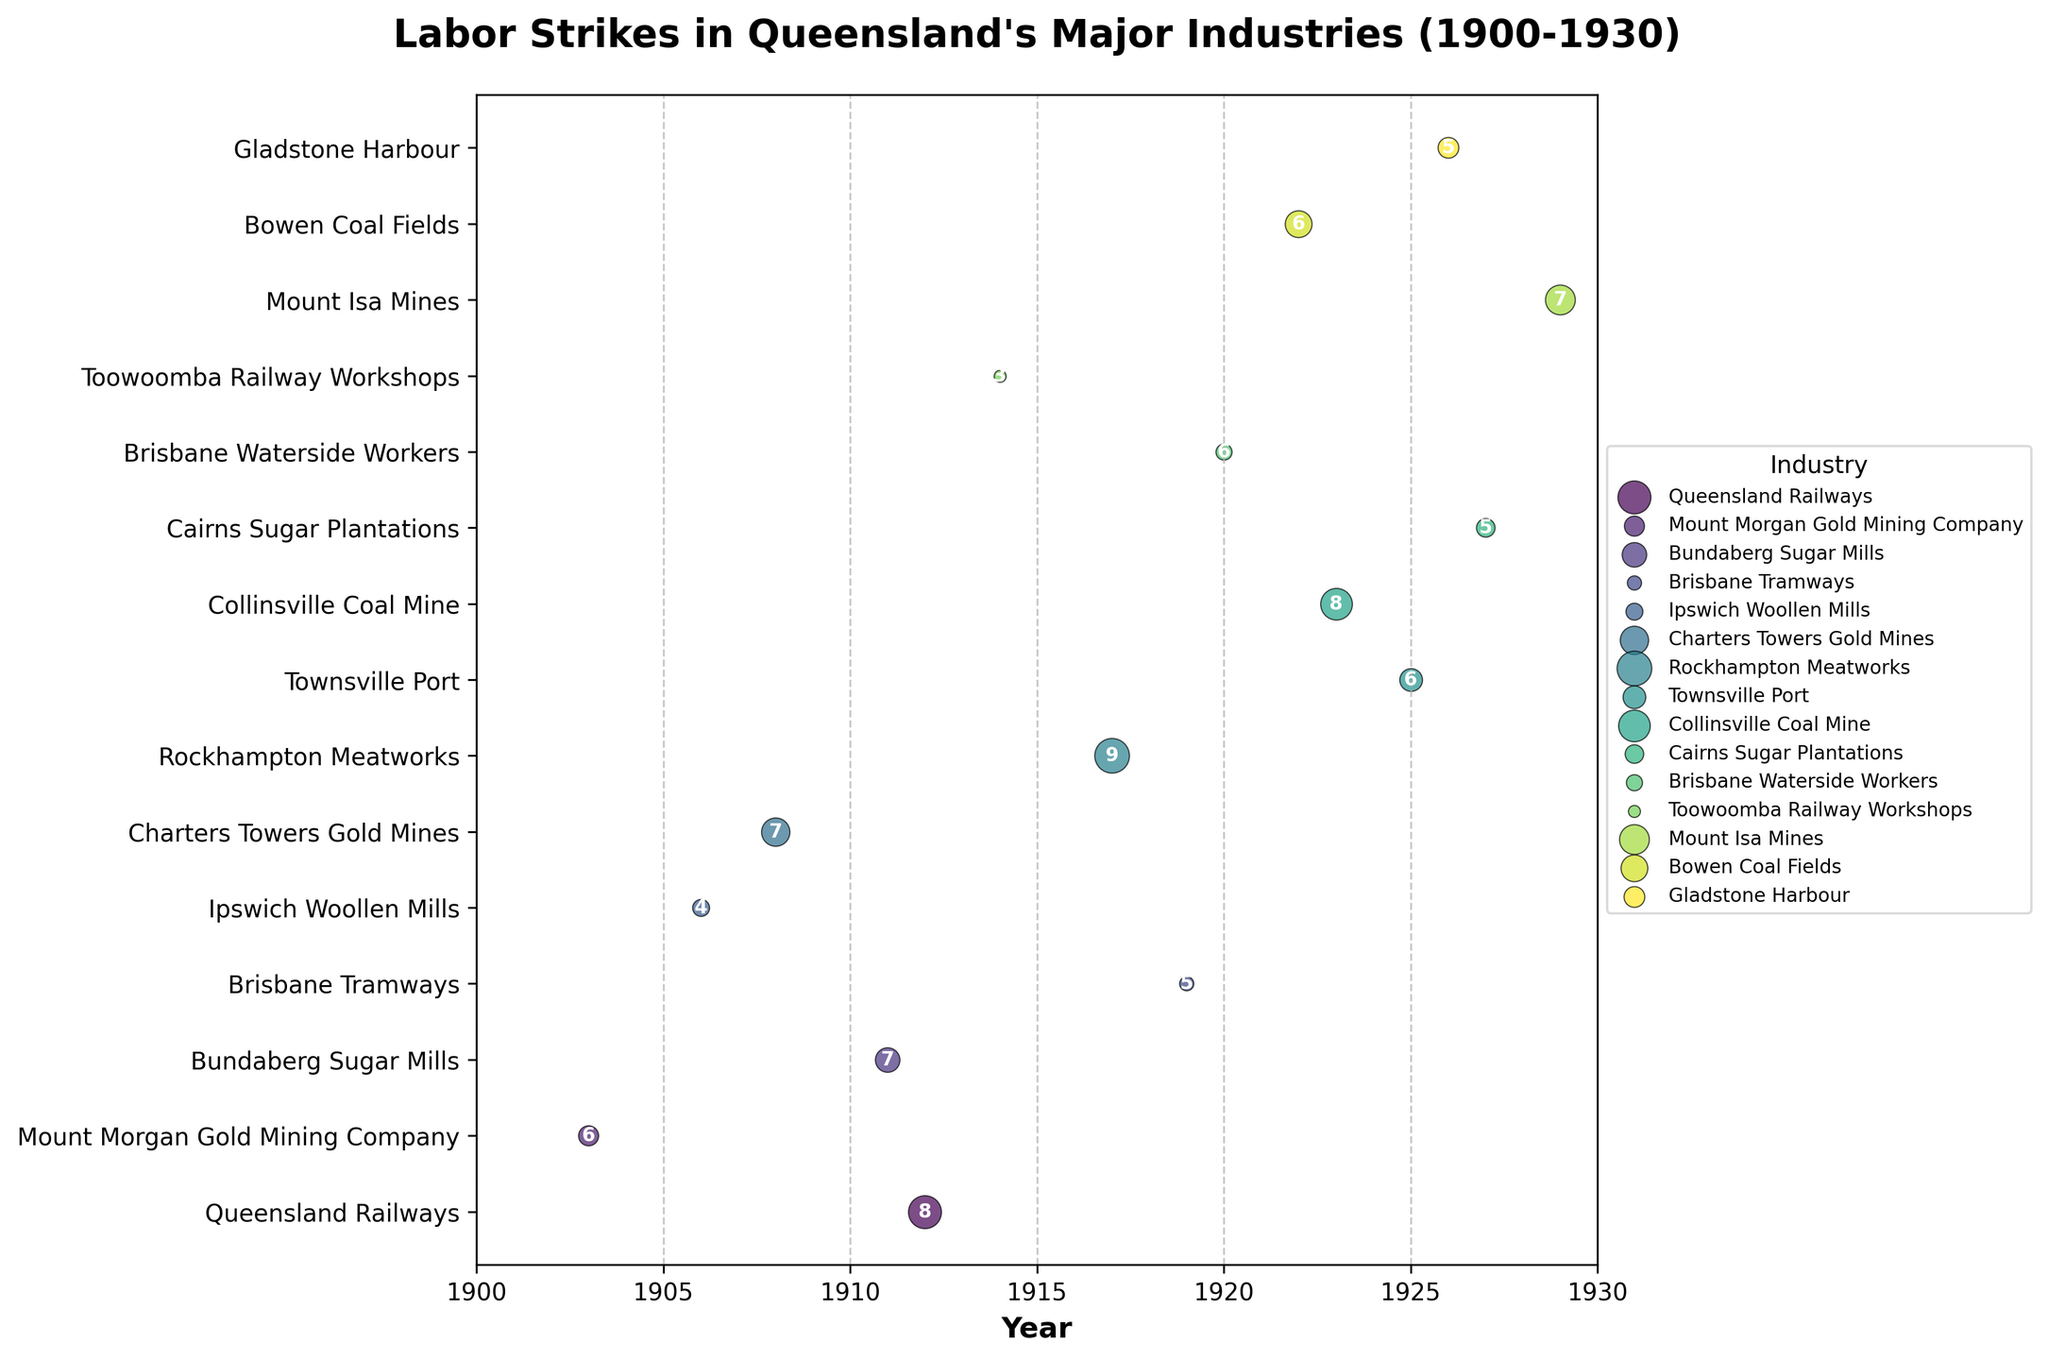What is the title of the plot? The title is located at the top of the plot and summarizes the data being displayed, which is about labor strikes in Queensland's major industries from 1900 to 1930.
Answer: Labor Strikes in Queensland's Major Industries (1900-1930) Which industry experienced the longest duration of a labor strike? To answer this, identify the industry associated with the largest circle. From the plot, the largest circle corresponds to the Rockhampton Meatworks.
Answer: Rockhampton Meatworks How many industries experienced labor strikes in 1912? Look for the vertical alignment of data points on the year 1912. Count the number of unique industries associated with these points. The plot shows one data point for Queensland Railways in 1912.
Answer: 1 Which industry had the highest intensity strike in 1923? Identify the strike in 1923, then look for the strike with the highest number inside the circle representing intensity. The plot shows Collinsville Coal Mine with an intensity of 8.
Answer: Collinsville Coal Mine In which year did the Brisbane Tramways experience a labor strike? Locate the specific industry on the y-axis and find the corresponding year on the x-axis. The Brisbane Tramways had its strike in 1919.
Answer: 1919 Which years had labor strikes in the gold mining industry? Identify the Charters Towers Gold Mines and Mount Morgan Gold Mining Company in the plot and list their corresponding years. They show strikes in 1903 and 1908.
Answer: 1903 and 1908 Compare the duration of labor strikes between Collinsville Coal Mine and Bowen Coal Fields. Which one had the longer strike? Observe the circle sizes for these two mines. The plot indicates Collinsville Coal Mine with a duration of 35 days and Bowen Coal Fields with 25 days.
Answer: Collinsville Coal Mine Which industry had the most recent labor strike in the timeframe of 1900-1930? Look at the data points furthest to the right on the x-axis. The most recent strike was for Mount Isa Mines in 1929.
Answer: Mount Isa Mines What was the intensity of the strike in the Ipswich Woollen Mills industry? Find the Ipswich Woollen Mills on the y-axis and identify the number inside its corresponding circle. The intensity is 4.
Answer: 4 How many industries had labor strikes in the year 1925? Count the data points that align vertically with the year 1925. The plot shows only one industry, Townsville Port, experiencing a strike in that year.
Answer: 1 